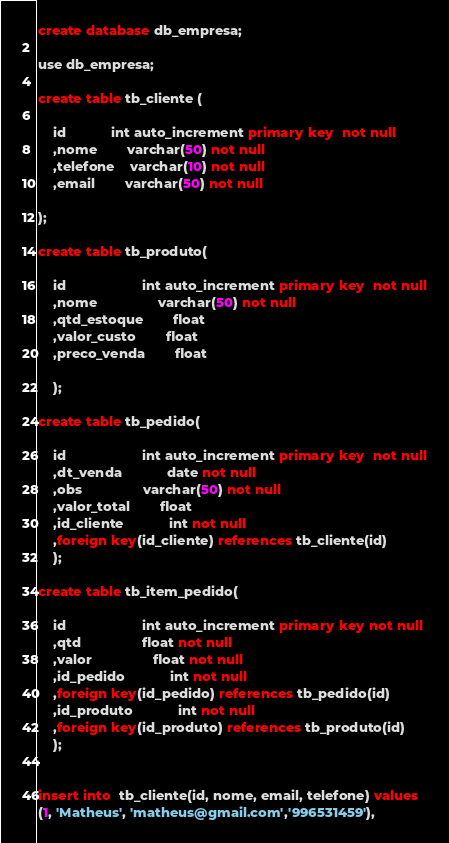<code> <loc_0><loc_0><loc_500><loc_500><_SQL_>create database db_empresa;

use db_empresa;

create table tb_cliente (

	id 			int auto_increment primary key  not null
    ,nome		varchar(50) not null
    ,telefone	varchar(10) not null
    ,email		varchar(50) not null

);

create table tb_produto(

	id					int auto_increment primary key  not null
    ,nome				varchar(50) not null
    ,qtd_estoque		float
    ,valor_custo		float
    ,preco_venda		float

    );

create table tb_pedido(

	id					int auto_increment primary key  not null
    ,dt_venda			date not null
    ,obs				varchar(50) not null
    ,valor_total 		float
    ,id_cliente			int not null
    ,foreign key(id_cliente) references tb_cliente(id)
    );

create table tb_item_pedido(

	id					int auto_increment primary key not null
    ,qtd				float not null
    ,valor				float not null
    ,id_pedido			int not null
    ,foreign key(id_pedido) references tb_pedido(id)
    ,id_produto			int not null
    ,foreign key(id_produto) references tb_produto(id)   
    );
	

insert into  tb_cliente(id, nome, email, telefone) values
(1, 'Matheus', 'matheus@gmail.com','996531459'),</code> 